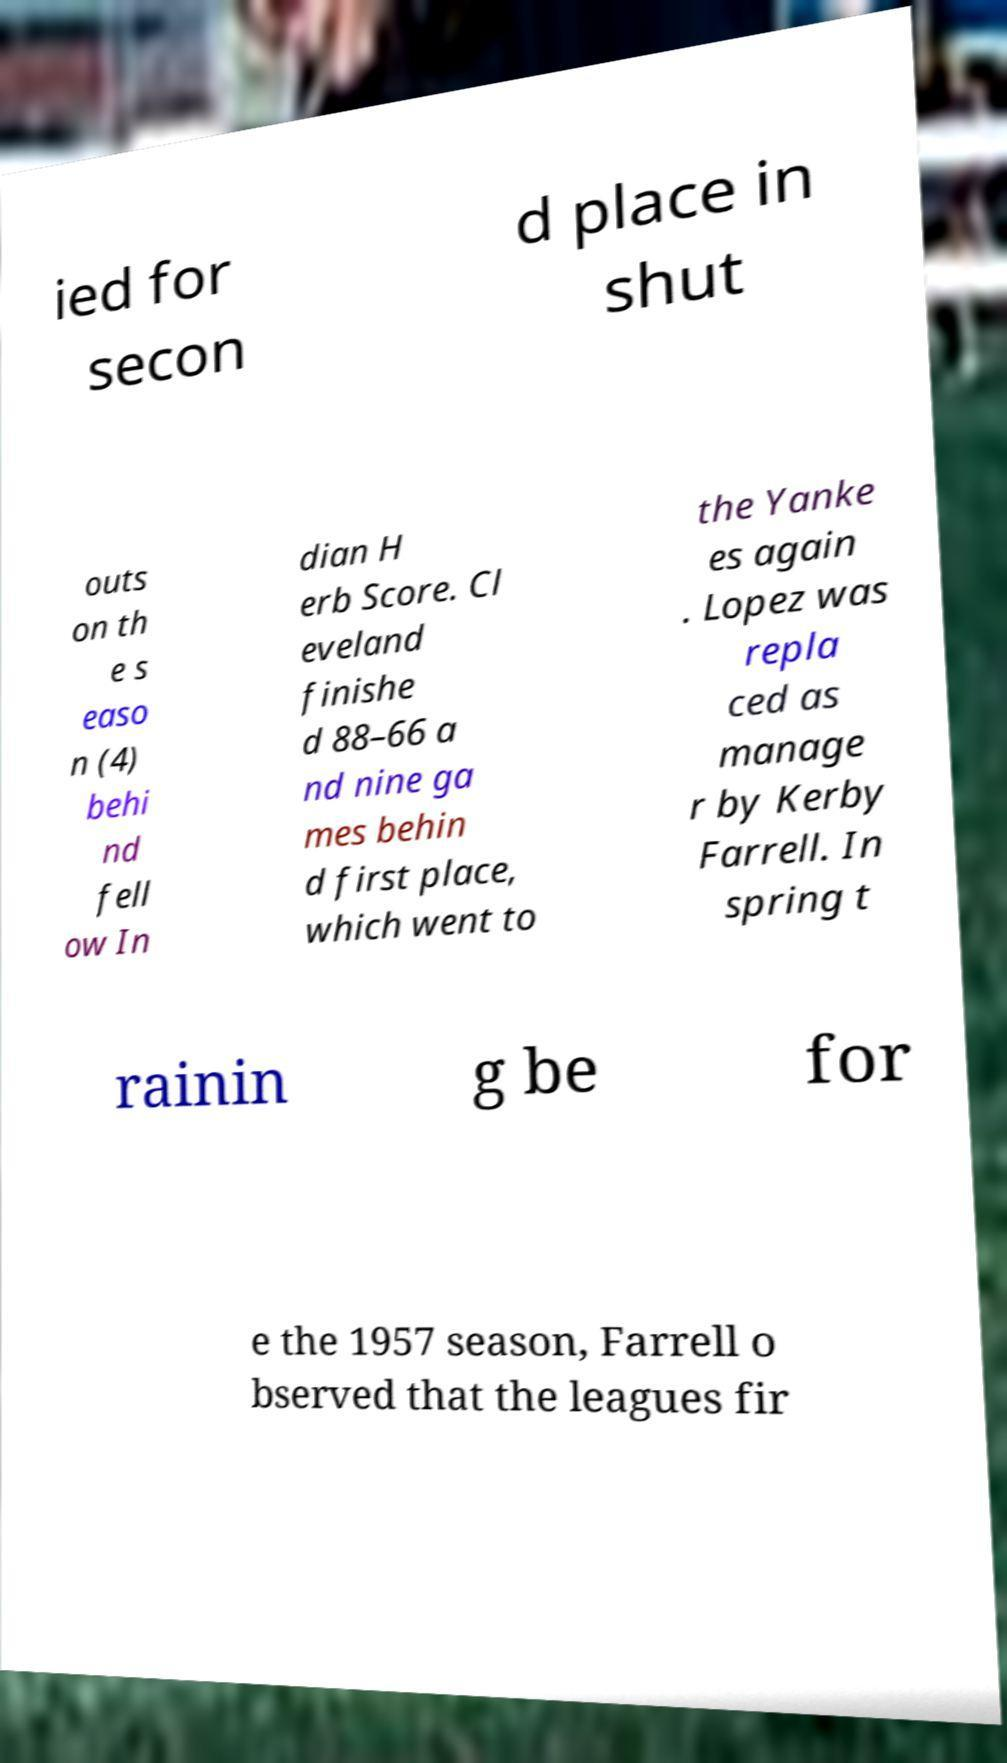What messages or text are displayed in this image? I need them in a readable, typed format. ied for secon d place in shut outs on th e s easo n (4) behi nd fell ow In dian H erb Score. Cl eveland finishe d 88–66 a nd nine ga mes behin d first place, which went to the Yanke es again . Lopez was repla ced as manage r by Kerby Farrell. In spring t rainin g be for e the 1957 season, Farrell o bserved that the leagues fir 